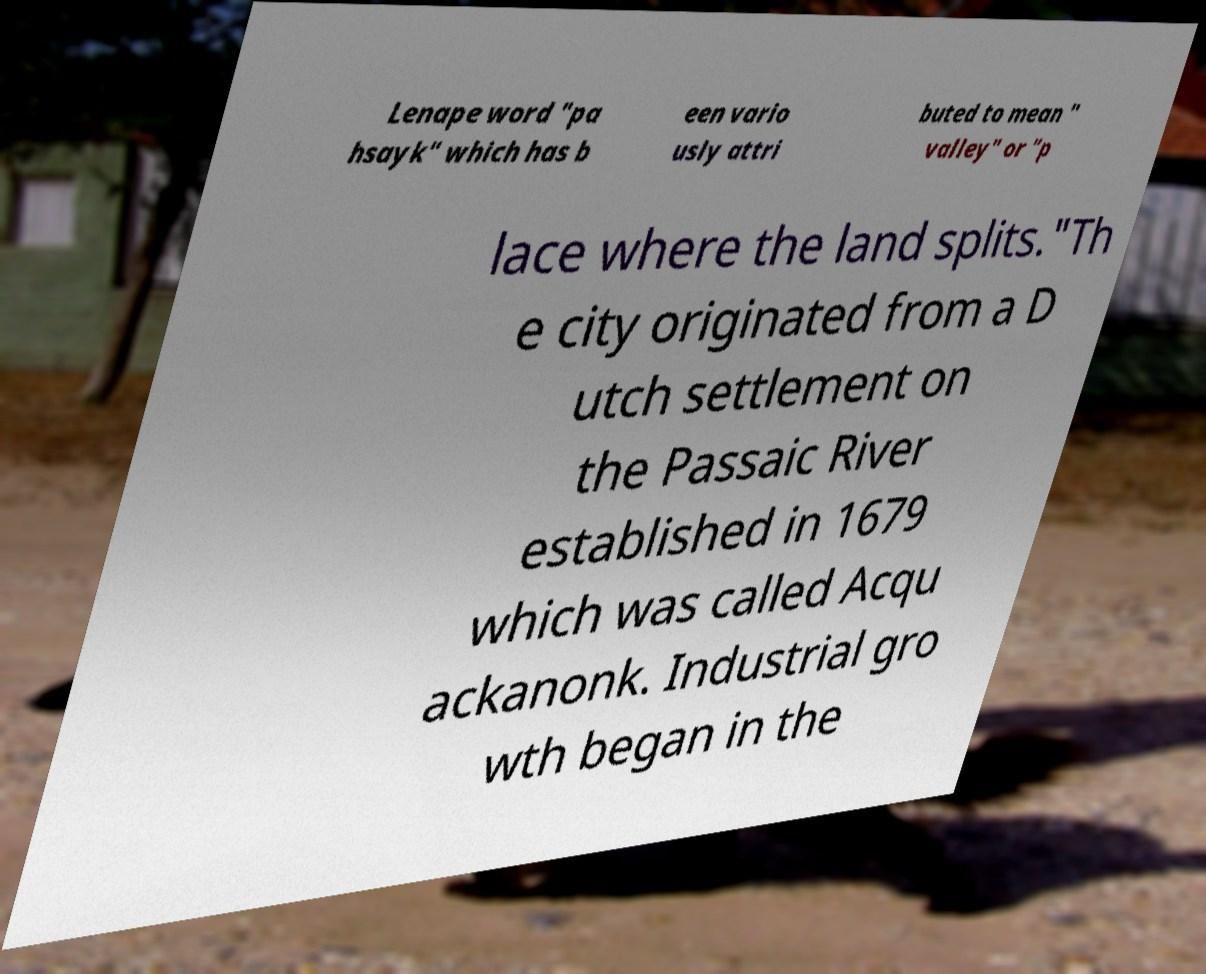For documentation purposes, I need the text within this image transcribed. Could you provide that? Lenape word "pa hsayk" which has b een vario usly attri buted to mean " valley" or "p lace where the land splits."Th e city originated from a D utch settlement on the Passaic River established in 1679 which was called Acqu ackanonk. Industrial gro wth began in the 